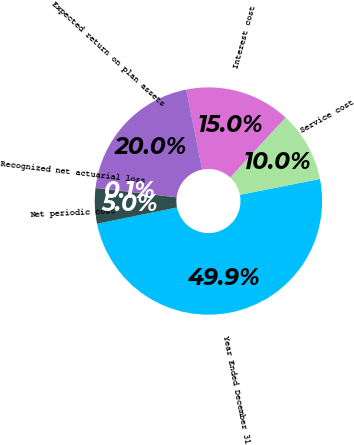Convert chart to OTSL. <chart><loc_0><loc_0><loc_500><loc_500><pie_chart><fcel>Year Ended December 31<fcel>Service cost<fcel>Interest cost<fcel>Expected return on plan assets<fcel>Recognized net actuarial loss<fcel>Net periodic cost<nl><fcel>49.9%<fcel>10.02%<fcel>15.0%<fcel>19.99%<fcel>0.05%<fcel>5.03%<nl></chart> 